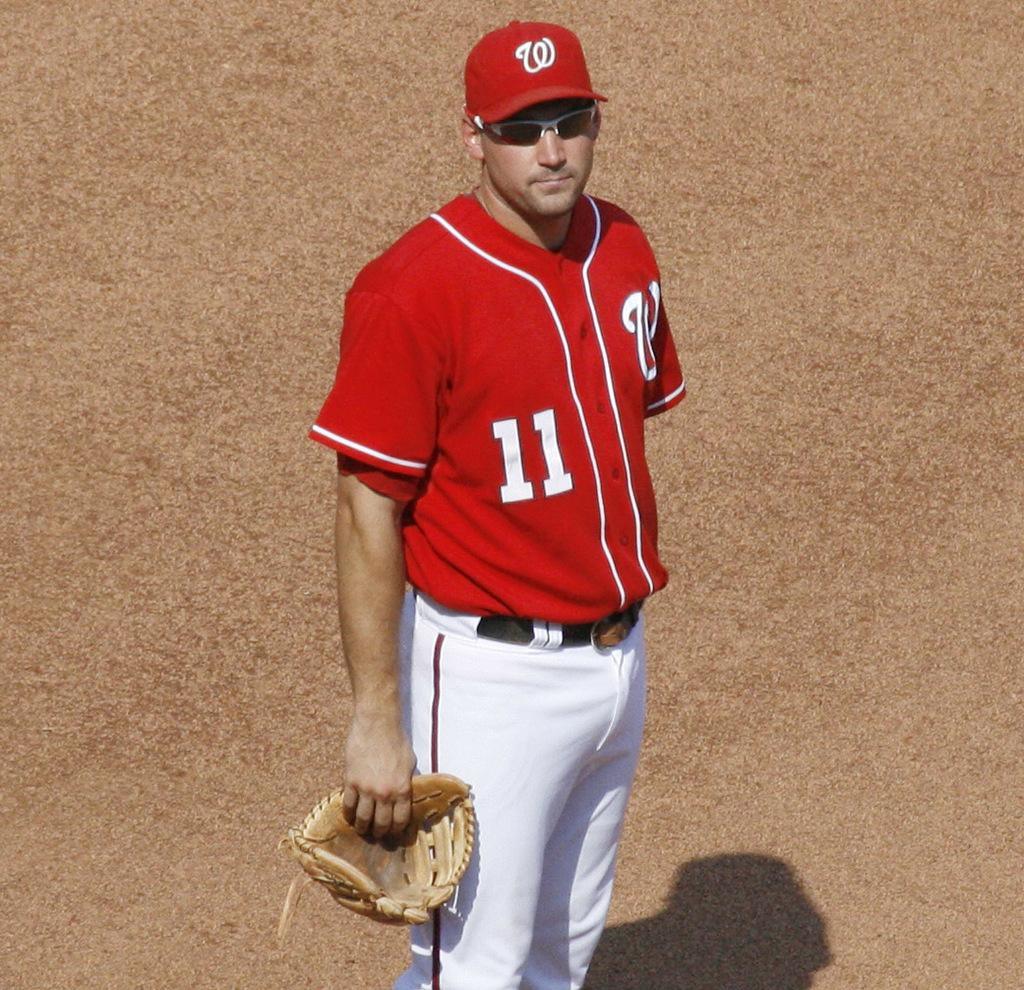Provide a one-sentence caption for the provided image. A player with number 11 on his red jersey holds a mitt in his right hand. 